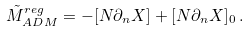Convert formula to latex. <formula><loc_0><loc_0><loc_500><loc_500>\tilde { M } _ { A D M } ^ { r e g } = - [ N \partial _ { n } X ] + [ N \partial _ { n } X ] _ { 0 } \, .</formula> 